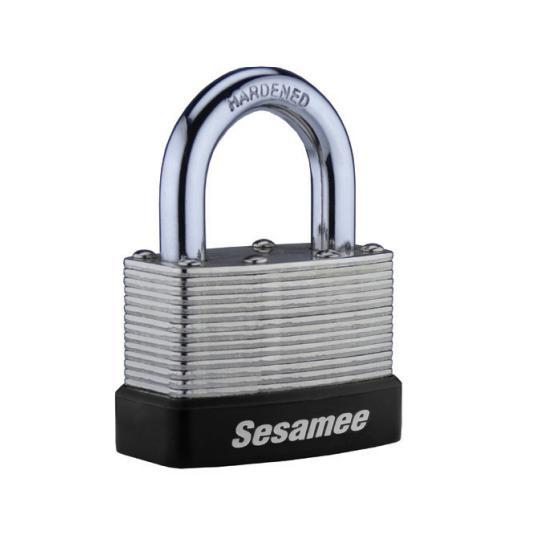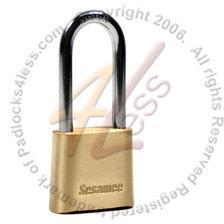The first image is the image on the left, the second image is the image on the right. Evaluate the accuracy of this statement regarding the images: "The body of both locks is made of gold colored metal.". Is it true? Answer yes or no. No. The first image is the image on the left, the second image is the image on the right. Evaluate the accuracy of this statement regarding the images: "Two locks are both roughly square shaped, but the metal loop of one lock is much longer than the loop of the other lock.". Is it true? Answer yes or no. Yes. 